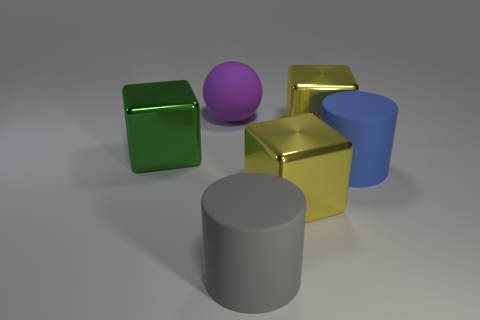Subtract all green shiny cubes. How many cubes are left? 2 Add 2 purple balls. How many objects exist? 8 Subtract all green cubes. How many cubes are left? 2 Add 3 blue matte cylinders. How many blue matte cylinders exist? 4 Subtract 0 gray spheres. How many objects are left? 6 Subtract all balls. How many objects are left? 5 Subtract 1 blocks. How many blocks are left? 2 Subtract all yellow cylinders. Subtract all yellow spheres. How many cylinders are left? 2 Subtract all blue cubes. How many gray cylinders are left? 1 Subtract all big yellow blocks. Subtract all metallic cubes. How many objects are left? 1 